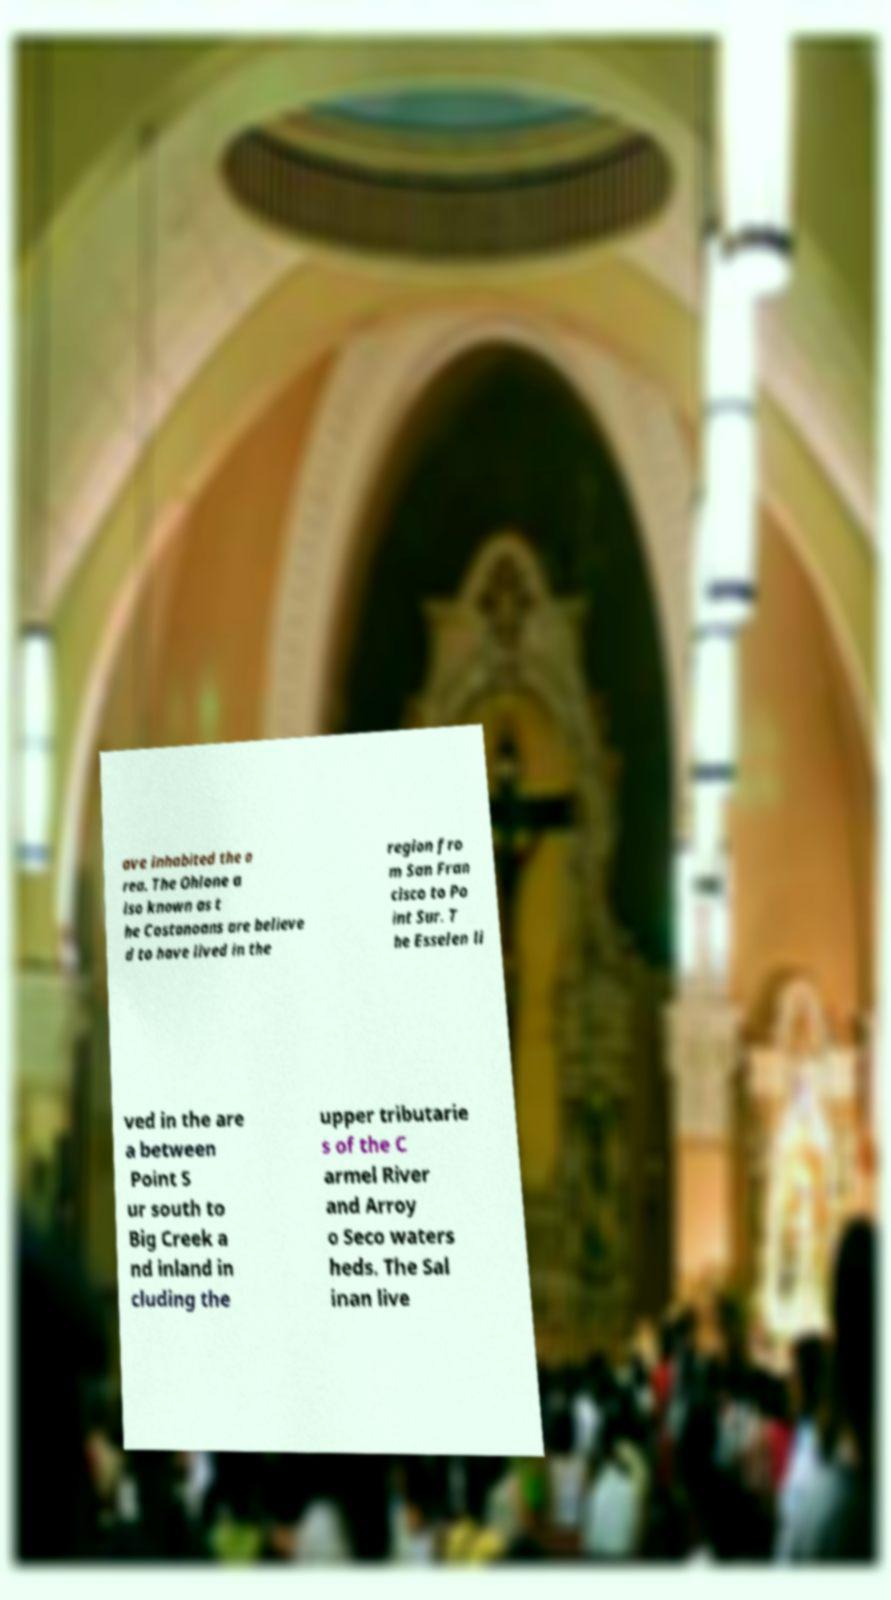Could you extract and type out the text from this image? ave inhabited the a rea. The Ohlone a lso known as t he Costanoans are believe d to have lived in the region fro m San Fran cisco to Po int Sur. T he Esselen li ved in the are a between Point S ur south to Big Creek a nd inland in cluding the upper tributarie s of the C armel River and Arroy o Seco waters heds. The Sal inan live 